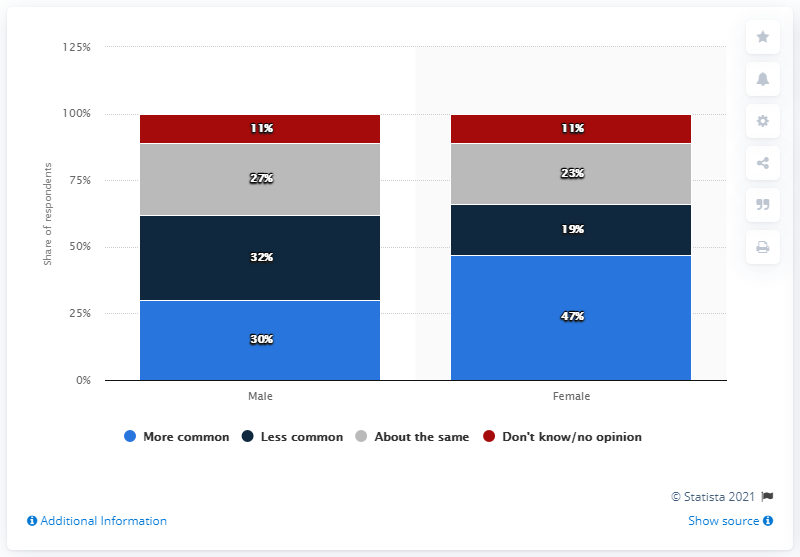Outline some significant characteristics in this image. According to the survey, 30% of male respondents believe that violence against women in TV shows is more prevalent today compared to five years ago. According to the survey, 47% of women believed that violence against women was more common today than five years ago. 